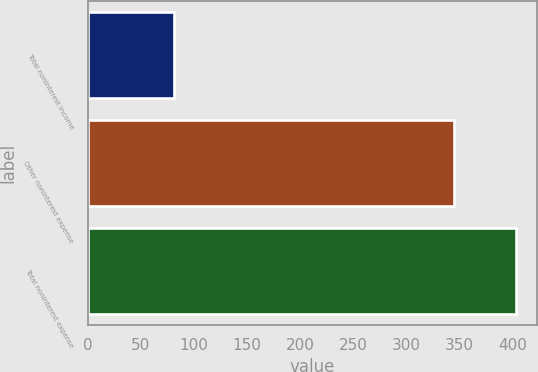Convert chart. <chart><loc_0><loc_0><loc_500><loc_500><bar_chart><fcel>Total noninterest income<fcel>Other noninterest expense<fcel>Total noninterest expense<nl><fcel>81<fcel>345<fcel>403<nl></chart> 